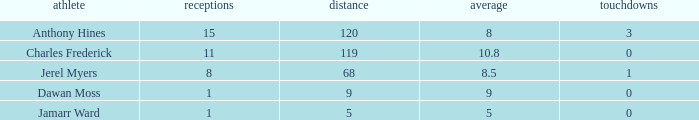Parse the full table. {'header': ['athlete', 'receptions', 'distance', 'average', 'touchdowns'], 'rows': [['Anthony Hines', '15', '120', '8', '3'], ['Charles Frederick', '11', '119', '10.8', '0'], ['Jerel Myers', '8', '68', '8.5', '1'], ['Dawan Moss', '1', '9', '9', '0'], ['Jamarr Ward', '1', '5', '5', '0']]} What is the total Avg when TDs are 0 and Dawan Moss is a player? 0.0. 